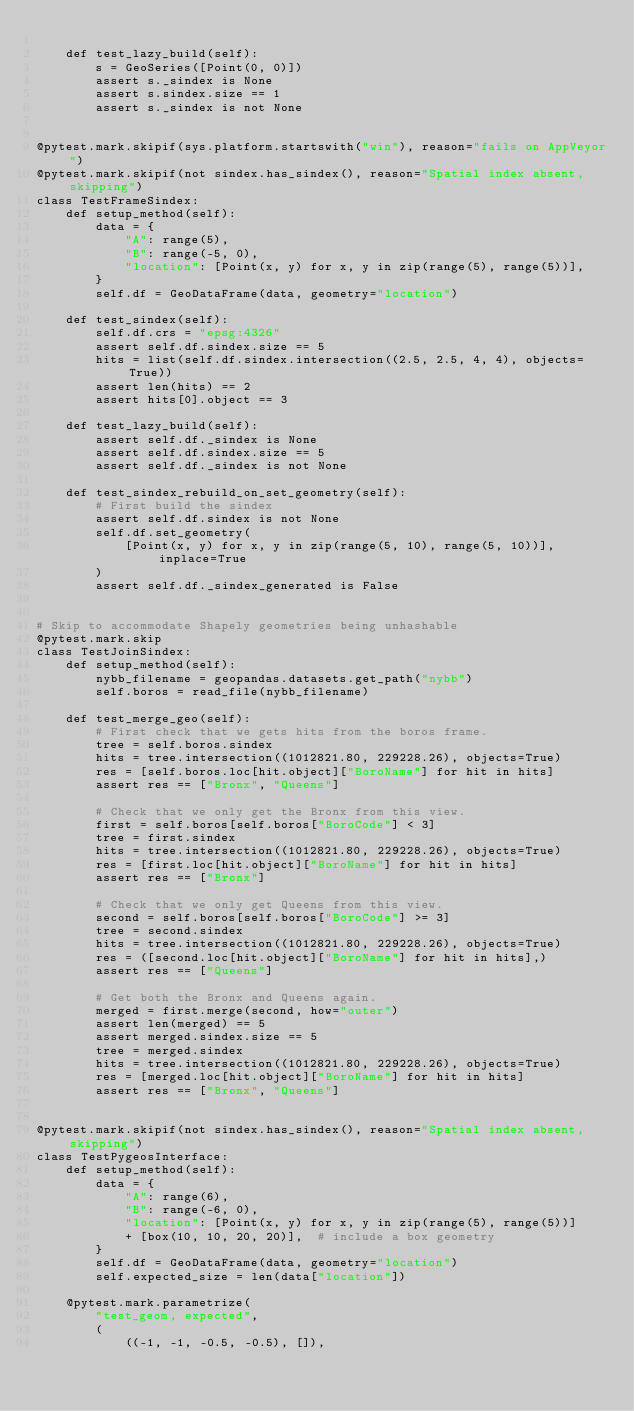<code> <loc_0><loc_0><loc_500><loc_500><_Python_>
    def test_lazy_build(self):
        s = GeoSeries([Point(0, 0)])
        assert s._sindex is None
        assert s.sindex.size == 1
        assert s._sindex is not None


@pytest.mark.skipif(sys.platform.startswith("win"), reason="fails on AppVeyor")
@pytest.mark.skipif(not sindex.has_sindex(), reason="Spatial index absent, skipping")
class TestFrameSindex:
    def setup_method(self):
        data = {
            "A": range(5),
            "B": range(-5, 0),
            "location": [Point(x, y) for x, y in zip(range(5), range(5))],
        }
        self.df = GeoDataFrame(data, geometry="location")

    def test_sindex(self):
        self.df.crs = "epsg:4326"
        assert self.df.sindex.size == 5
        hits = list(self.df.sindex.intersection((2.5, 2.5, 4, 4), objects=True))
        assert len(hits) == 2
        assert hits[0].object == 3

    def test_lazy_build(self):
        assert self.df._sindex is None
        assert self.df.sindex.size == 5
        assert self.df._sindex is not None

    def test_sindex_rebuild_on_set_geometry(self):
        # First build the sindex
        assert self.df.sindex is not None
        self.df.set_geometry(
            [Point(x, y) for x, y in zip(range(5, 10), range(5, 10))], inplace=True
        )
        assert self.df._sindex_generated is False


# Skip to accommodate Shapely geometries being unhashable
@pytest.mark.skip
class TestJoinSindex:
    def setup_method(self):
        nybb_filename = geopandas.datasets.get_path("nybb")
        self.boros = read_file(nybb_filename)

    def test_merge_geo(self):
        # First check that we gets hits from the boros frame.
        tree = self.boros.sindex
        hits = tree.intersection((1012821.80, 229228.26), objects=True)
        res = [self.boros.loc[hit.object]["BoroName"] for hit in hits]
        assert res == ["Bronx", "Queens"]

        # Check that we only get the Bronx from this view.
        first = self.boros[self.boros["BoroCode"] < 3]
        tree = first.sindex
        hits = tree.intersection((1012821.80, 229228.26), objects=True)
        res = [first.loc[hit.object]["BoroName"] for hit in hits]
        assert res == ["Bronx"]

        # Check that we only get Queens from this view.
        second = self.boros[self.boros["BoroCode"] >= 3]
        tree = second.sindex
        hits = tree.intersection((1012821.80, 229228.26), objects=True)
        res = ([second.loc[hit.object]["BoroName"] for hit in hits],)
        assert res == ["Queens"]

        # Get both the Bronx and Queens again.
        merged = first.merge(second, how="outer")
        assert len(merged) == 5
        assert merged.sindex.size == 5
        tree = merged.sindex
        hits = tree.intersection((1012821.80, 229228.26), objects=True)
        res = [merged.loc[hit.object]["BoroName"] for hit in hits]
        assert res == ["Bronx", "Queens"]


@pytest.mark.skipif(not sindex.has_sindex(), reason="Spatial index absent, skipping")
class TestPygeosInterface:
    def setup_method(self):
        data = {
            "A": range(6),
            "B": range(-6, 0),
            "location": [Point(x, y) for x, y in zip(range(5), range(5))]
            + [box(10, 10, 20, 20)],  # include a box geometry
        }
        self.df = GeoDataFrame(data, geometry="location")
        self.expected_size = len(data["location"])

    @pytest.mark.parametrize(
        "test_geom, expected",
        (
            ((-1, -1, -0.5, -0.5), []),</code> 